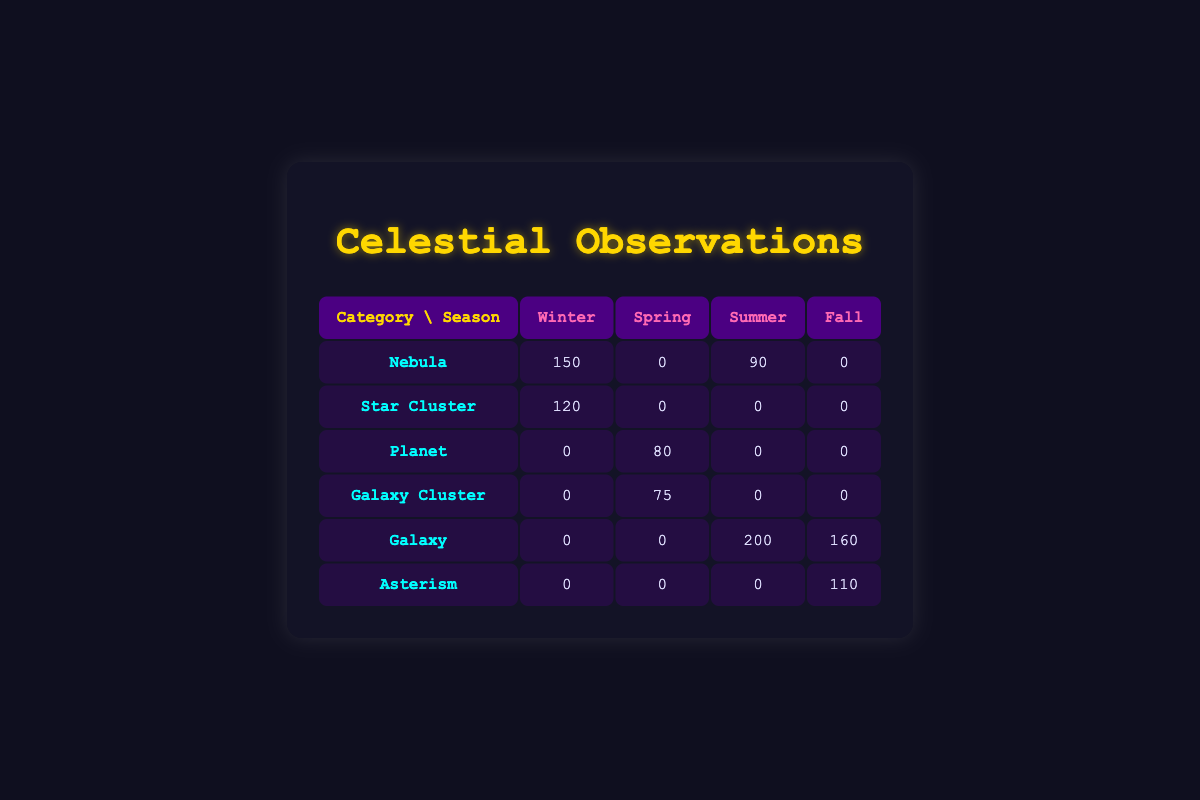What is the total number of observations for galaxies across all seasons? The table shows that there are two entries for the galaxy category. For summer, there are 200 observations, and for fall, there are 160 observations. Summing these gives us 200 + 160 = 360.
Answer: 360 During which season was the Orion Nebula observed the most? The Orion Nebula is listed under the winter season with 150 observations. There are no observations recorded in spring, summer, or fall for this object. Therefore, winter is when it was observed the most.
Answer: Winter Is the Lagoon Nebula categorized under galaxies? The Lagoon Nebula is listed under the "Nebula" category. Therefore, it is not categorized as a galaxy.
Answer: No What is the difference in the number of observations between the Andromeda Galaxy and the Lagoon Nebula? The Andromeda Galaxy has 160 observations recorded in the fall, while the Lagoon Nebula has 90 observations in summer. The difference is 160 - 90 = 70.
Answer: 70 Which season has the highest total number of observations across all categories? By summing observations for each season: Winter (150 + 120) = 270, Spring (80 + 75) = 155, Summer (200 + 90) = 290, and Fall (160 + 110) = 270. Summer has the highest total with 290 observations.
Answer: Summer 